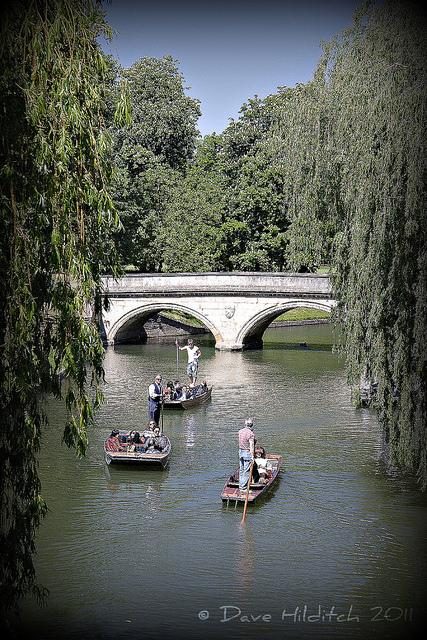Why are some people standing in the boats?

Choices:
A) angry
B) tipping boat
C) diving
D) gondoliers gondoliers 